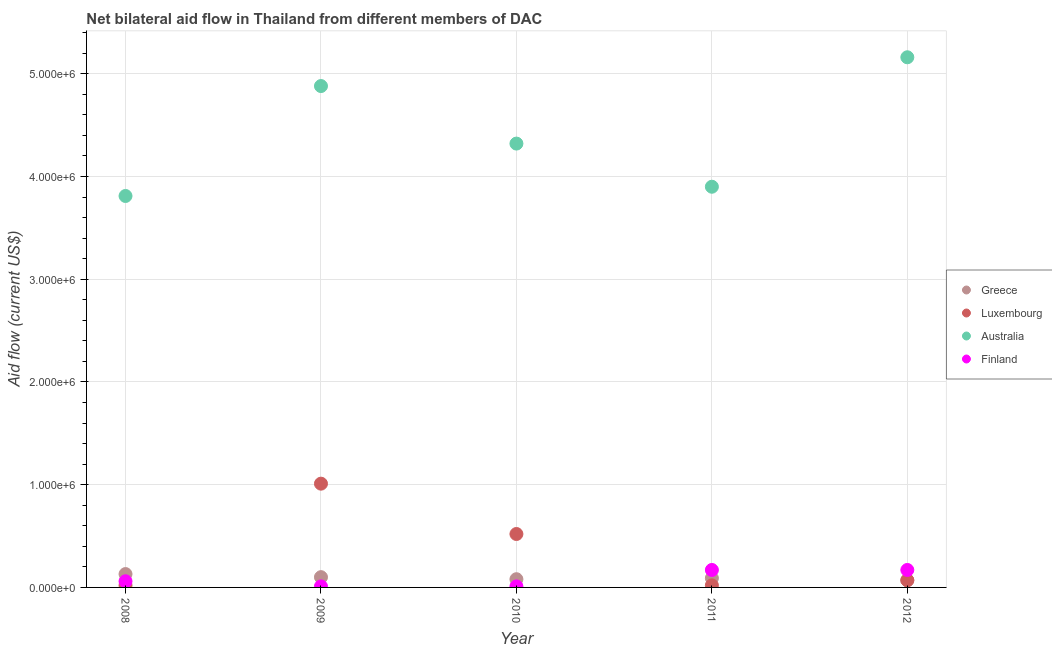How many different coloured dotlines are there?
Offer a terse response. 4. What is the amount of aid given by greece in 2009?
Your answer should be very brief. 1.00e+05. Across all years, what is the maximum amount of aid given by greece?
Give a very brief answer. 1.30e+05. Across all years, what is the minimum amount of aid given by luxembourg?
Your response must be concise. 2.00e+04. In which year was the amount of aid given by luxembourg maximum?
Provide a succinct answer. 2009. What is the total amount of aid given by luxembourg in the graph?
Offer a terse response. 1.64e+06. What is the difference between the amount of aid given by australia in 2010 and that in 2012?
Provide a short and direct response. -8.40e+05. What is the difference between the amount of aid given by greece in 2011 and the amount of aid given by australia in 2009?
Offer a terse response. -4.79e+06. What is the average amount of aid given by luxembourg per year?
Ensure brevity in your answer.  3.28e+05. In the year 2009, what is the difference between the amount of aid given by luxembourg and amount of aid given by australia?
Your answer should be compact. -3.87e+06. What is the ratio of the amount of aid given by greece in 2011 to that in 2012?
Make the answer very short. 1.29. What is the difference between the highest and the second highest amount of aid given by finland?
Ensure brevity in your answer.  0. What is the difference between the highest and the lowest amount of aid given by finland?
Your answer should be compact. 1.60e+05. In how many years, is the amount of aid given by luxembourg greater than the average amount of aid given by luxembourg taken over all years?
Make the answer very short. 2. Is the sum of the amount of aid given by luxembourg in 2010 and 2011 greater than the maximum amount of aid given by australia across all years?
Your response must be concise. No. Does the graph contain grids?
Your answer should be compact. Yes. How many legend labels are there?
Offer a very short reply. 4. What is the title of the graph?
Your response must be concise. Net bilateral aid flow in Thailand from different members of DAC. Does "Compensation of employees" appear as one of the legend labels in the graph?
Make the answer very short. No. What is the label or title of the X-axis?
Keep it short and to the point. Year. What is the label or title of the Y-axis?
Your answer should be compact. Aid flow (current US$). What is the Aid flow (current US$) in Luxembourg in 2008?
Keep it short and to the point. 2.00e+04. What is the Aid flow (current US$) in Australia in 2008?
Your response must be concise. 3.81e+06. What is the Aid flow (current US$) of Greece in 2009?
Offer a terse response. 1.00e+05. What is the Aid flow (current US$) in Luxembourg in 2009?
Make the answer very short. 1.01e+06. What is the Aid flow (current US$) in Australia in 2009?
Give a very brief answer. 4.88e+06. What is the Aid flow (current US$) in Finland in 2009?
Your answer should be very brief. 10000. What is the Aid flow (current US$) of Greece in 2010?
Make the answer very short. 8.00e+04. What is the Aid flow (current US$) of Luxembourg in 2010?
Ensure brevity in your answer.  5.20e+05. What is the Aid flow (current US$) in Australia in 2010?
Make the answer very short. 4.32e+06. What is the Aid flow (current US$) of Greece in 2011?
Offer a very short reply. 9.00e+04. What is the Aid flow (current US$) of Luxembourg in 2011?
Ensure brevity in your answer.  2.00e+04. What is the Aid flow (current US$) in Australia in 2011?
Ensure brevity in your answer.  3.90e+06. What is the Aid flow (current US$) of Finland in 2011?
Keep it short and to the point. 1.70e+05. What is the Aid flow (current US$) in Australia in 2012?
Provide a succinct answer. 5.16e+06. What is the Aid flow (current US$) of Finland in 2012?
Provide a short and direct response. 1.70e+05. Across all years, what is the maximum Aid flow (current US$) of Greece?
Keep it short and to the point. 1.30e+05. Across all years, what is the maximum Aid flow (current US$) of Luxembourg?
Your answer should be very brief. 1.01e+06. Across all years, what is the maximum Aid flow (current US$) in Australia?
Your answer should be very brief. 5.16e+06. Across all years, what is the minimum Aid flow (current US$) in Greece?
Offer a terse response. 7.00e+04. Across all years, what is the minimum Aid flow (current US$) in Luxembourg?
Offer a very short reply. 2.00e+04. Across all years, what is the minimum Aid flow (current US$) of Australia?
Offer a terse response. 3.81e+06. Across all years, what is the minimum Aid flow (current US$) in Finland?
Give a very brief answer. 10000. What is the total Aid flow (current US$) of Greece in the graph?
Offer a terse response. 4.70e+05. What is the total Aid flow (current US$) in Luxembourg in the graph?
Provide a succinct answer. 1.64e+06. What is the total Aid flow (current US$) in Australia in the graph?
Your answer should be very brief. 2.21e+07. What is the difference between the Aid flow (current US$) of Luxembourg in 2008 and that in 2009?
Provide a succinct answer. -9.90e+05. What is the difference between the Aid flow (current US$) in Australia in 2008 and that in 2009?
Offer a terse response. -1.07e+06. What is the difference between the Aid flow (current US$) in Luxembourg in 2008 and that in 2010?
Offer a very short reply. -5.00e+05. What is the difference between the Aid flow (current US$) of Australia in 2008 and that in 2010?
Make the answer very short. -5.10e+05. What is the difference between the Aid flow (current US$) in Greece in 2008 and that in 2011?
Offer a very short reply. 4.00e+04. What is the difference between the Aid flow (current US$) of Australia in 2008 and that in 2011?
Offer a very short reply. -9.00e+04. What is the difference between the Aid flow (current US$) of Finland in 2008 and that in 2011?
Your answer should be very brief. -1.10e+05. What is the difference between the Aid flow (current US$) in Luxembourg in 2008 and that in 2012?
Offer a terse response. -5.00e+04. What is the difference between the Aid flow (current US$) in Australia in 2008 and that in 2012?
Provide a short and direct response. -1.35e+06. What is the difference between the Aid flow (current US$) of Finland in 2008 and that in 2012?
Make the answer very short. -1.10e+05. What is the difference between the Aid flow (current US$) in Greece in 2009 and that in 2010?
Offer a very short reply. 2.00e+04. What is the difference between the Aid flow (current US$) in Australia in 2009 and that in 2010?
Ensure brevity in your answer.  5.60e+05. What is the difference between the Aid flow (current US$) of Luxembourg in 2009 and that in 2011?
Your response must be concise. 9.90e+05. What is the difference between the Aid flow (current US$) of Australia in 2009 and that in 2011?
Give a very brief answer. 9.80e+05. What is the difference between the Aid flow (current US$) of Finland in 2009 and that in 2011?
Offer a terse response. -1.60e+05. What is the difference between the Aid flow (current US$) of Luxembourg in 2009 and that in 2012?
Your response must be concise. 9.40e+05. What is the difference between the Aid flow (current US$) of Australia in 2009 and that in 2012?
Your answer should be very brief. -2.80e+05. What is the difference between the Aid flow (current US$) in Australia in 2010 and that in 2011?
Your answer should be very brief. 4.20e+05. What is the difference between the Aid flow (current US$) of Finland in 2010 and that in 2011?
Your response must be concise. -1.60e+05. What is the difference between the Aid flow (current US$) in Australia in 2010 and that in 2012?
Your answer should be very brief. -8.40e+05. What is the difference between the Aid flow (current US$) of Finland in 2010 and that in 2012?
Keep it short and to the point. -1.60e+05. What is the difference between the Aid flow (current US$) of Australia in 2011 and that in 2012?
Offer a very short reply. -1.26e+06. What is the difference between the Aid flow (current US$) of Finland in 2011 and that in 2012?
Provide a short and direct response. 0. What is the difference between the Aid flow (current US$) in Greece in 2008 and the Aid flow (current US$) in Luxembourg in 2009?
Your response must be concise. -8.80e+05. What is the difference between the Aid flow (current US$) of Greece in 2008 and the Aid flow (current US$) of Australia in 2009?
Your answer should be very brief. -4.75e+06. What is the difference between the Aid flow (current US$) in Luxembourg in 2008 and the Aid flow (current US$) in Australia in 2009?
Offer a very short reply. -4.86e+06. What is the difference between the Aid flow (current US$) of Luxembourg in 2008 and the Aid flow (current US$) of Finland in 2009?
Offer a terse response. 10000. What is the difference between the Aid flow (current US$) in Australia in 2008 and the Aid flow (current US$) in Finland in 2009?
Your answer should be compact. 3.80e+06. What is the difference between the Aid flow (current US$) in Greece in 2008 and the Aid flow (current US$) in Luxembourg in 2010?
Your response must be concise. -3.90e+05. What is the difference between the Aid flow (current US$) in Greece in 2008 and the Aid flow (current US$) in Australia in 2010?
Give a very brief answer. -4.19e+06. What is the difference between the Aid flow (current US$) of Greece in 2008 and the Aid flow (current US$) of Finland in 2010?
Ensure brevity in your answer.  1.20e+05. What is the difference between the Aid flow (current US$) in Luxembourg in 2008 and the Aid flow (current US$) in Australia in 2010?
Make the answer very short. -4.30e+06. What is the difference between the Aid flow (current US$) of Australia in 2008 and the Aid flow (current US$) of Finland in 2010?
Ensure brevity in your answer.  3.80e+06. What is the difference between the Aid flow (current US$) in Greece in 2008 and the Aid flow (current US$) in Australia in 2011?
Keep it short and to the point. -3.77e+06. What is the difference between the Aid flow (current US$) of Greece in 2008 and the Aid flow (current US$) of Finland in 2011?
Offer a terse response. -4.00e+04. What is the difference between the Aid flow (current US$) in Luxembourg in 2008 and the Aid flow (current US$) in Australia in 2011?
Your response must be concise. -3.88e+06. What is the difference between the Aid flow (current US$) of Luxembourg in 2008 and the Aid flow (current US$) of Finland in 2011?
Make the answer very short. -1.50e+05. What is the difference between the Aid flow (current US$) in Australia in 2008 and the Aid flow (current US$) in Finland in 2011?
Your answer should be compact. 3.64e+06. What is the difference between the Aid flow (current US$) in Greece in 2008 and the Aid flow (current US$) in Luxembourg in 2012?
Offer a very short reply. 6.00e+04. What is the difference between the Aid flow (current US$) in Greece in 2008 and the Aid flow (current US$) in Australia in 2012?
Provide a succinct answer. -5.03e+06. What is the difference between the Aid flow (current US$) of Greece in 2008 and the Aid flow (current US$) of Finland in 2012?
Make the answer very short. -4.00e+04. What is the difference between the Aid flow (current US$) in Luxembourg in 2008 and the Aid flow (current US$) in Australia in 2012?
Offer a very short reply. -5.14e+06. What is the difference between the Aid flow (current US$) of Australia in 2008 and the Aid flow (current US$) of Finland in 2012?
Ensure brevity in your answer.  3.64e+06. What is the difference between the Aid flow (current US$) in Greece in 2009 and the Aid flow (current US$) in Luxembourg in 2010?
Your answer should be very brief. -4.20e+05. What is the difference between the Aid flow (current US$) of Greece in 2009 and the Aid flow (current US$) of Australia in 2010?
Provide a short and direct response. -4.22e+06. What is the difference between the Aid flow (current US$) of Luxembourg in 2009 and the Aid flow (current US$) of Australia in 2010?
Give a very brief answer. -3.31e+06. What is the difference between the Aid flow (current US$) of Australia in 2009 and the Aid flow (current US$) of Finland in 2010?
Keep it short and to the point. 4.87e+06. What is the difference between the Aid flow (current US$) of Greece in 2009 and the Aid flow (current US$) of Australia in 2011?
Offer a very short reply. -3.80e+06. What is the difference between the Aid flow (current US$) in Greece in 2009 and the Aid flow (current US$) in Finland in 2011?
Offer a terse response. -7.00e+04. What is the difference between the Aid flow (current US$) of Luxembourg in 2009 and the Aid flow (current US$) of Australia in 2011?
Keep it short and to the point. -2.89e+06. What is the difference between the Aid flow (current US$) of Luxembourg in 2009 and the Aid flow (current US$) of Finland in 2011?
Provide a succinct answer. 8.40e+05. What is the difference between the Aid flow (current US$) of Australia in 2009 and the Aid flow (current US$) of Finland in 2011?
Your answer should be very brief. 4.71e+06. What is the difference between the Aid flow (current US$) of Greece in 2009 and the Aid flow (current US$) of Australia in 2012?
Provide a succinct answer. -5.06e+06. What is the difference between the Aid flow (current US$) in Greece in 2009 and the Aid flow (current US$) in Finland in 2012?
Provide a succinct answer. -7.00e+04. What is the difference between the Aid flow (current US$) in Luxembourg in 2009 and the Aid flow (current US$) in Australia in 2012?
Offer a terse response. -4.15e+06. What is the difference between the Aid flow (current US$) of Luxembourg in 2009 and the Aid flow (current US$) of Finland in 2012?
Your response must be concise. 8.40e+05. What is the difference between the Aid flow (current US$) in Australia in 2009 and the Aid flow (current US$) in Finland in 2012?
Make the answer very short. 4.71e+06. What is the difference between the Aid flow (current US$) in Greece in 2010 and the Aid flow (current US$) in Australia in 2011?
Make the answer very short. -3.82e+06. What is the difference between the Aid flow (current US$) in Luxembourg in 2010 and the Aid flow (current US$) in Australia in 2011?
Keep it short and to the point. -3.38e+06. What is the difference between the Aid flow (current US$) of Australia in 2010 and the Aid flow (current US$) of Finland in 2011?
Your answer should be compact. 4.15e+06. What is the difference between the Aid flow (current US$) in Greece in 2010 and the Aid flow (current US$) in Luxembourg in 2012?
Make the answer very short. 10000. What is the difference between the Aid flow (current US$) of Greece in 2010 and the Aid flow (current US$) of Australia in 2012?
Your response must be concise. -5.08e+06. What is the difference between the Aid flow (current US$) in Greece in 2010 and the Aid flow (current US$) in Finland in 2012?
Give a very brief answer. -9.00e+04. What is the difference between the Aid flow (current US$) in Luxembourg in 2010 and the Aid flow (current US$) in Australia in 2012?
Offer a terse response. -4.64e+06. What is the difference between the Aid flow (current US$) of Australia in 2010 and the Aid flow (current US$) of Finland in 2012?
Provide a succinct answer. 4.15e+06. What is the difference between the Aid flow (current US$) in Greece in 2011 and the Aid flow (current US$) in Australia in 2012?
Make the answer very short. -5.07e+06. What is the difference between the Aid flow (current US$) of Greece in 2011 and the Aid flow (current US$) of Finland in 2012?
Make the answer very short. -8.00e+04. What is the difference between the Aid flow (current US$) of Luxembourg in 2011 and the Aid flow (current US$) of Australia in 2012?
Offer a very short reply. -5.14e+06. What is the difference between the Aid flow (current US$) in Australia in 2011 and the Aid flow (current US$) in Finland in 2012?
Ensure brevity in your answer.  3.73e+06. What is the average Aid flow (current US$) of Greece per year?
Offer a very short reply. 9.40e+04. What is the average Aid flow (current US$) of Luxembourg per year?
Your response must be concise. 3.28e+05. What is the average Aid flow (current US$) of Australia per year?
Your response must be concise. 4.41e+06. What is the average Aid flow (current US$) in Finland per year?
Make the answer very short. 8.40e+04. In the year 2008, what is the difference between the Aid flow (current US$) of Greece and Aid flow (current US$) of Luxembourg?
Provide a short and direct response. 1.10e+05. In the year 2008, what is the difference between the Aid flow (current US$) of Greece and Aid flow (current US$) of Australia?
Give a very brief answer. -3.68e+06. In the year 2008, what is the difference between the Aid flow (current US$) in Greece and Aid flow (current US$) in Finland?
Your answer should be compact. 7.00e+04. In the year 2008, what is the difference between the Aid flow (current US$) in Luxembourg and Aid flow (current US$) in Australia?
Your answer should be compact. -3.79e+06. In the year 2008, what is the difference between the Aid flow (current US$) of Luxembourg and Aid flow (current US$) of Finland?
Give a very brief answer. -4.00e+04. In the year 2008, what is the difference between the Aid flow (current US$) in Australia and Aid flow (current US$) in Finland?
Your response must be concise. 3.75e+06. In the year 2009, what is the difference between the Aid flow (current US$) of Greece and Aid flow (current US$) of Luxembourg?
Give a very brief answer. -9.10e+05. In the year 2009, what is the difference between the Aid flow (current US$) of Greece and Aid flow (current US$) of Australia?
Keep it short and to the point. -4.78e+06. In the year 2009, what is the difference between the Aid flow (current US$) of Greece and Aid flow (current US$) of Finland?
Keep it short and to the point. 9.00e+04. In the year 2009, what is the difference between the Aid flow (current US$) of Luxembourg and Aid flow (current US$) of Australia?
Make the answer very short. -3.87e+06. In the year 2009, what is the difference between the Aid flow (current US$) in Australia and Aid flow (current US$) in Finland?
Offer a very short reply. 4.87e+06. In the year 2010, what is the difference between the Aid flow (current US$) of Greece and Aid flow (current US$) of Luxembourg?
Your response must be concise. -4.40e+05. In the year 2010, what is the difference between the Aid flow (current US$) of Greece and Aid flow (current US$) of Australia?
Your answer should be very brief. -4.24e+06. In the year 2010, what is the difference between the Aid flow (current US$) of Luxembourg and Aid flow (current US$) of Australia?
Give a very brief answer. -3.80e+06. In the year 2010, what is the difference between the Aid flow (current US$) of Luxembourg and Aid flow (current US$) of Finland?
Provide a succinct answer. 5.10e+05. In the year 2010, what is the difference between the Aid flow (current US$) of Australia and Aid flow (current US$) of Finland?
Ensure brevity in your answer.  4.31e+06. In the year 2011, what is the difference between the Aid flow (current US$) of Greece and Aid flow (current US$) of Australia?
Ensure brevity in your answer.  -3.81e+06. In the year 2011, what is the difference between the Aid flow (current US$) of Luxembourg and Aid flow (current US$) of Australia?
Offer a terse response. -3.88e+06. In the year 2011, what is the difference between the Aid flow (current US$) in Australia and Aid flow (current US$) in Finland?
Give a very brief answer. 3.73e+06. In the year 2012, what is the difference between the Aid flow (current US$) of Greece and Aid flow (current US$) of Australia?
Keep it short and to the point. -5.09e+06. In the year 2012, what is the difference between the Aid flow (current US$) in Greece and Aid flow (current US$) in Finland?
Offer a terse response. -1.00e+05. In the year 2012, what is the difference between the Aid flow (current US$) in Luxembourg and Aid flow (current US$) in Australia?
Make the answer very short. -5.09e+06. In the year 2012, what is the difference between the Aid flow (current US$) of Luxembourg and Aid flow (current US$) of Finland?
Ensure brevity in your answer.  -1.00e+05. In the year 2012, what is the difference between the Aid flow (current US$) in Australia and Aid flow (current US$) in Finland?
Keep it short and to the point. 4.99e+06. What is the ratio of the Aid flow (current US$) in Luxembourg in 2008 to that in 2009?
Make the answer very short. 0.02. What is the ratio of the Aid flow (current US$) in Australia in 2008 to that in 2009?
Provide a short and direct response. 0.78. What is the ratio of the Aid flow (current US$) in Greece in 2008 to that in 2010?
Make the answer very short. 1.62. What is the ratio of the Aid flow (current US$) in Luxembourg in 2008 to that in 2010?
Your answer should be compact. 0.04. What is the ratio of the Aid flow (current US$) of Australia in 2008 to that in 2010?
Provide a succinct answer. 0.88. What is the ratio of the Aid flow (current US$) in Finland in 2008 to that in 2010?
Offer a very short reply. 6. What is the ratio of the Aid flow (current US$) of Greece in 2008 to that in 2011?
Make the answer very short. 1.44. What is the ratio of the Aid flow (current US$) in Luxembourg in 2008 to that in 2011?
Keep it short and to the point. 1. What is the ratio of the Aid flow (current US$) in Australia in 2008 to that in 2011?
Give a very brief answer. 0.98. What is the ratio of the Aid flow (current US$) in Finland in 2008 to that in 2011?
Keep it short and to the point. 0.35. What is the ratio of the Aid flow (current US$) in Greece in 2008 to that in 2012?
Make the answer very short. 1.86. What is the ratio of the Aid flow (current US$) in Luxembourg in 2008 to that in 2012?
Make the answer very short. 0.29. What is the ratio of the Aid flow (current US$) in Australia in 2008 to that in 2012?
Your answer should be very brief. 0.74. What is the ratio of the Aid flow (current US$) in Finland in 2008 to that in 2012?
Provide a succinct answer. 0.35. What is the ratio of the Aid flow (current US$) of Greece in 2009 to that in 2010?
Ensure brevity in your answer.  1.25. What is the ratio of the Aid flow (current US$) in Luxembourg in 2009 to that in 2010?
Provide a short and direct response. 1.94. What is the ratio of the Aid flow (current US$) in Australia in 2009 to that in 2010?
Give a very brief answer. 1.13. What is the ratio of the Aid flow (current US$) of Luxembourg in 2009 to that in 2011?
Provide a short and direct response. 50.5. What is the ratio of the Aid flow (current US$) of Australia in 2009 to that in 2011?
Provide a short and direct response. 1.25. What is the ratio of the Aid flow (current US$) of Finland in 2009 to that in 2011?
Provide a succinct answer. 0.06. What is the ratio of the Aid flow (current US$) of Greece in 2009 to that in 2012?
Your answer should be compact. 1.43. What is the ratio of the Aid flow (current US$) in Luxembourg in 2009 to that in 2012?
Provide a succinct answer. 14.43. What is the ratio of the Aid flow (current US$) in Australia in 2009 to that in 2012?
Offer a very short reply. 0.95. What is the ratio of the Aid flow (current US$) of Finland in 2009 to that in 2012?
Your response must be concise. 0.06. What is the ratio of the Aid flow (current US$) in Greece in 2010 to that in 2011?
Your answer should be compact. 0.89. What is the ratio of the Aid flow (current US$) in Luxembourg in 2010 to that in 2011?
Provide a succinct answer. 26. What is the ratio of the Aid flow (current US$) of Australia in 2010 to that in 2011?
Your answer should be compact. 1.11. What is the ratio of the Aid flow (current US$) of Finland in 2010 to that in 2011?
Offer a terse response. 0.06. What is the ratio of the Aid flow (current US$) of Luxembourg in 2010 to that in 2012?
Your answer should be compact. 7.43. What is the ratio of the Aid flow (current US$) of Australia in 2010 to that in 2012?
Ensure brevity in your answer.  0.84. What is the ratio of the Aid flow (current US$) in Finland in 2010 to that in 2012?
Offer a very short reply. 0.06. What is the ratio of the Aid flow (current US$) in Greece in 2011 to that in 2012?
Your answer should be very brief. 1.29. What is the ratio of the Aid flow (current US$) in Luxembourg in 2011 to that in 2012?
Make the answer very short. 0.29. What is the ratio of the Aid flow (current US$) of Australia in 2011 to that in 2012?
Your response must be concise. 0.76. What is the difference between the highest and the second highest Aid flow (current US$) in Greece?
Make the answer very short. 3.00e+04. What is the difference between the highest and the second highest Aid flow (current US$) of Luxembourg?
Offer a very short reply. 4.90e+05. What is the difference between the highest and the lowest Aid flow (current US$) of Luxembourg?
Offer a very short reply. 9.90e+05. What is the difference between the highest and the lowest Aid flow (current US$) of Australia?
Offer a terse response. 1.35e+06. 